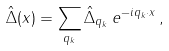Convert formula to latex. <formula><loc_0><loc_0><loc_500><loc_500>\hat { \Delta } ( x ) = \sum _ { q _ { k } } \hat { \Delta } _ { q _ { k } } \, e ^ { - i q _ { k } \cdot x } \, ,</formula> 